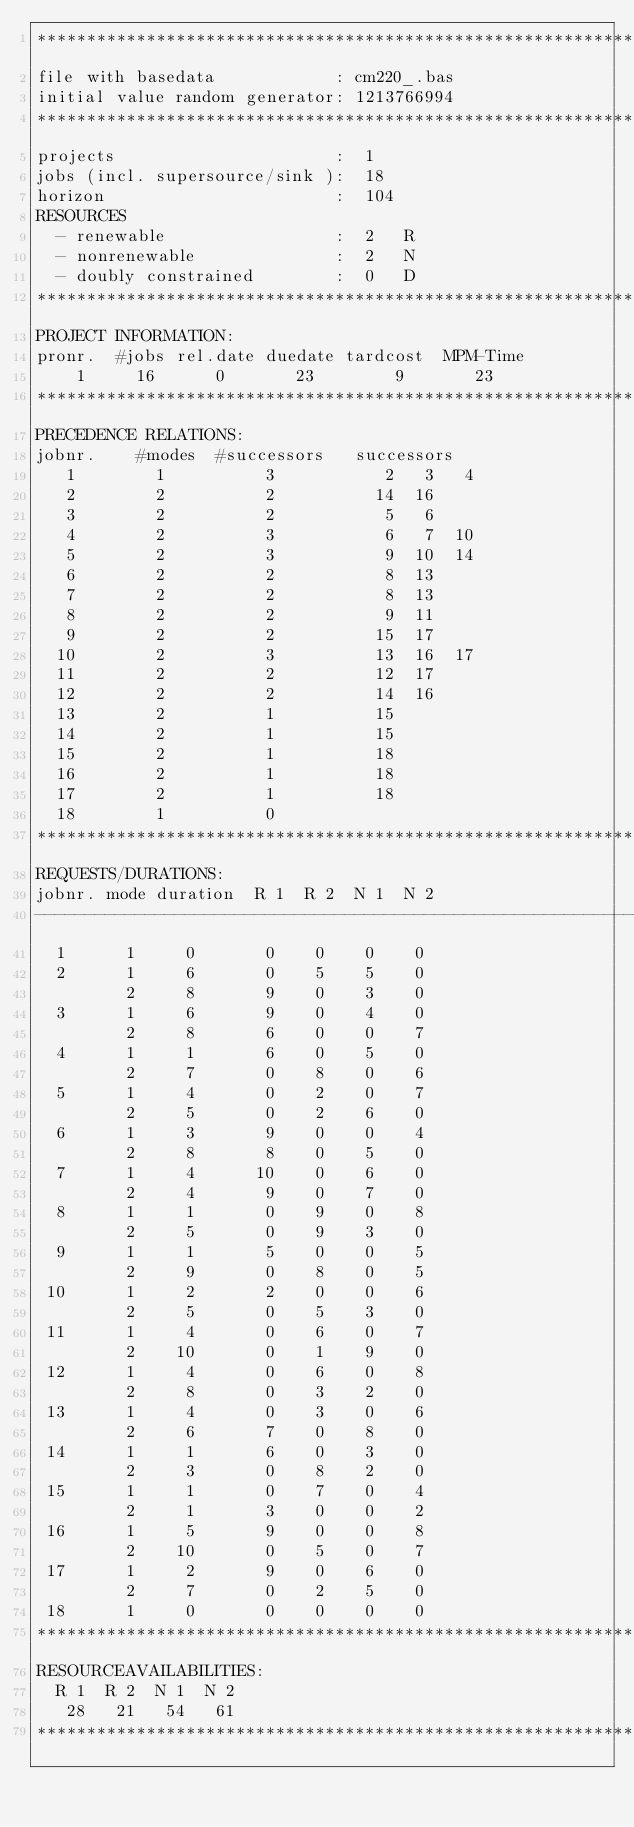<code> <loc_0><loc_0><loc_500><loc_500><_ObjectiveC_>************************************************************************
file with basedata            : cm220_.bas
initial value random generator: 1213766994
************************************************************************
projects                      :  1
jobs (incl. supersource/sink ):  18
horizon                       :  104
RESOURCES
  - renewable                 :  2   R
  - nonrenewable              :  2   N
  - doubly constrained        :  0   D
************************************************************************
PROJECT INFORMATION:
pronr.  #jobs rel.date duedate tardcost  MPM-Time
    1     16      0       23        9       23
************************************************************************
PRECEDENCE RELATIONS:
jobnr.    #modes  #successors   successors
   1        1          3           2   3   4
   2        2          2          14  16
   3        2          2           5   6
   4        2          3           6   7  10
   5        2          3           9  10  14
   6        2          2           8  13
   7        2          2           8  13
   8        2          2           9  11
   9        2          2          15  17
  10        2          3          13  16  17
  11        2          2          12  17
  12        2          2          14  16
  13        2          1          15
  14        2          1          15
  15        2          1          18
  16        2          1          18
  17        2          1          18
  18        1          0        
************************************************************************
REQUESTS/DURATIONS:
jobnr. mode duration  R 1  R 2  N 1  N 2
------------------------------------------------------------------------
  1      1     0       0    0    0    0
  2      1     6       0    5    5    0
         2     8       9    0    3    0
  3      1     6       9    0    4    0
         2     8       6    0    0    7
  4      1     1       6    0    5    0
         2     7       0    8    0    6
  5      1     4       0    2    0    7
         2     5       0    2    6    0
  6      1     3       9    0    0    4
         2     8       8    0    5    0
  7      1     4      10    0    6    0
         2     4       9    0    7    0
  8      1     1       0    9    0    8
         2     5       0    9    3    0
  9      1     1       5    0    0    5
         2     9       0    8    0    5
 10      1     2       2    0    0    6
         2     5       0    5    3    0
 11      1     4       0    6    0    7
         2    10       0    1    9    0
 12      1     4       0    6    0    8
         2     8       0    3    2    0
 13      1     4       0    3    0    6
         2     6       7    0    8    0
 14      1     1       6    0    3    0
         2     3       0    8    2    0
 15      1     1       0    7    0    4
         2     1       3    0    0    2
 16      1     5       9    0    0    8
         2    10       0    5    0    7
 17      1     2       9    0    6    0
         2     7       0    2    5    0
 18      1     0       0    0    0    0
************************************************************************
RESOURCEAVAILABILITIES:
  R 1  R 2  N 1  N 2
   28   21   54   61
************************************************************************
</code> 